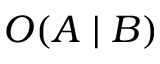<formula> <loc_0><loc_0><loc_500><loc_500>O ( A | B )</formula> 